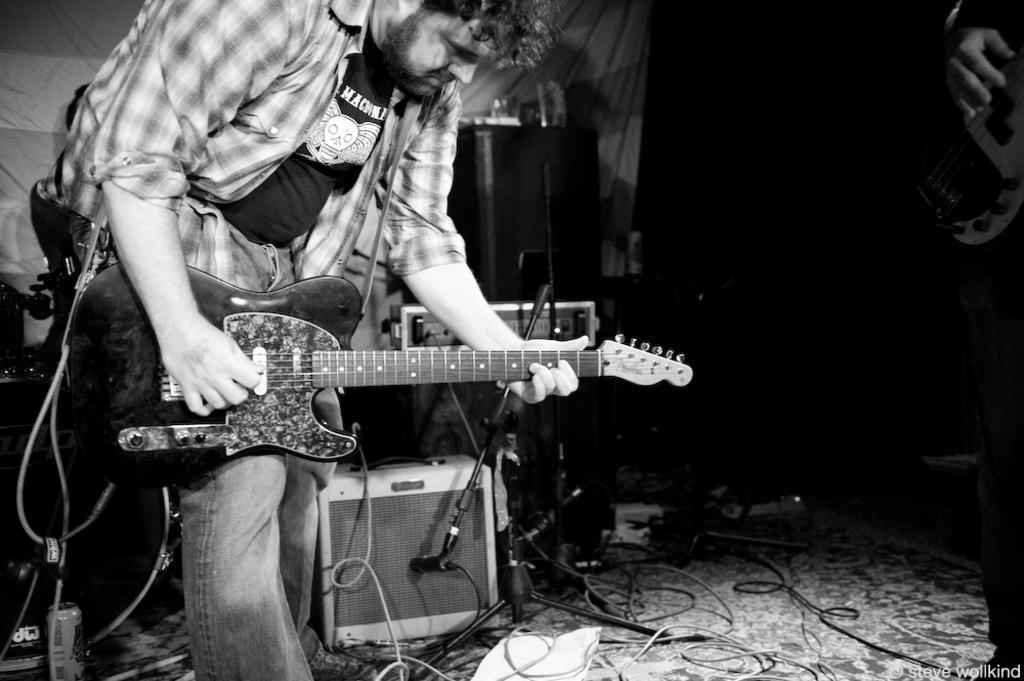In one or two sentences, can you explain what this image depicts? In this picture there is a man who is playing a guitar and he is wearing a check shirt. On the bottom there is a musical instrument and lots of wires which are connected to the instrument. On the top right corner there is an another man who is holding a guitar. 